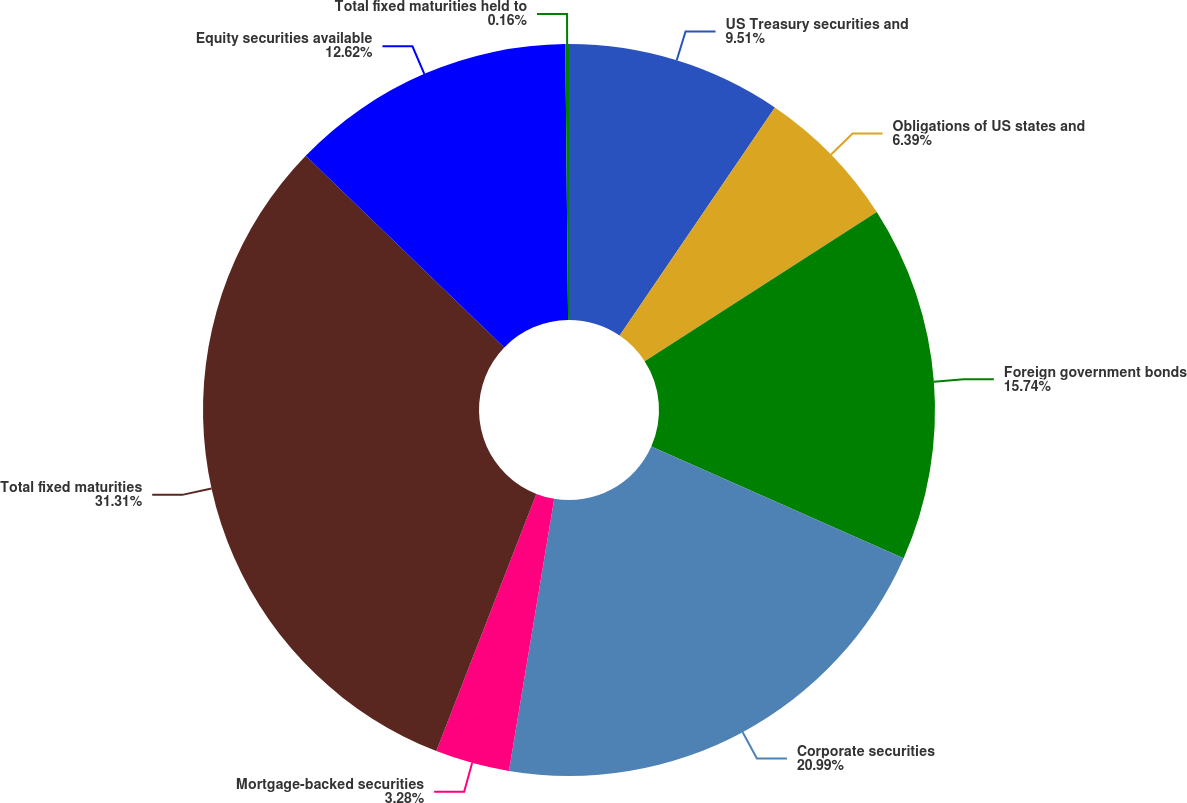<chart> <loc_0><loc_0><loc_500><loc_500><pie_chart><fcel>US Treasury securities and<fcel>Obligations of US states and<fcel>Foreign government bonds<fcel>Corporate securities<fcel>Mortgage-backed securities<fcel>Total fixed maturities<fcel>Equity securities available<fcel>Total fixed maturities held to<nl><fcel>9.51%<fcel>6.39%<fcel>15.74%<fcel>20.99%<fcel>3.28%<fcel>31.32%<fcel>12.62%<fcel>0.16%<nl></chart> 